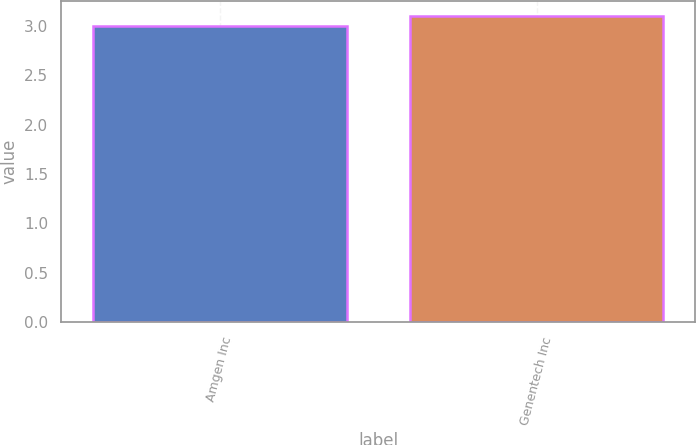Convert chart to OTSL. <chart><loc_0><loc_0><loc_500><loc_500><bar_chart><fcel>Amgen Inc<fcel>Genentech Inc<nl><fcel>3<fcel>3.1<nl></chart> 